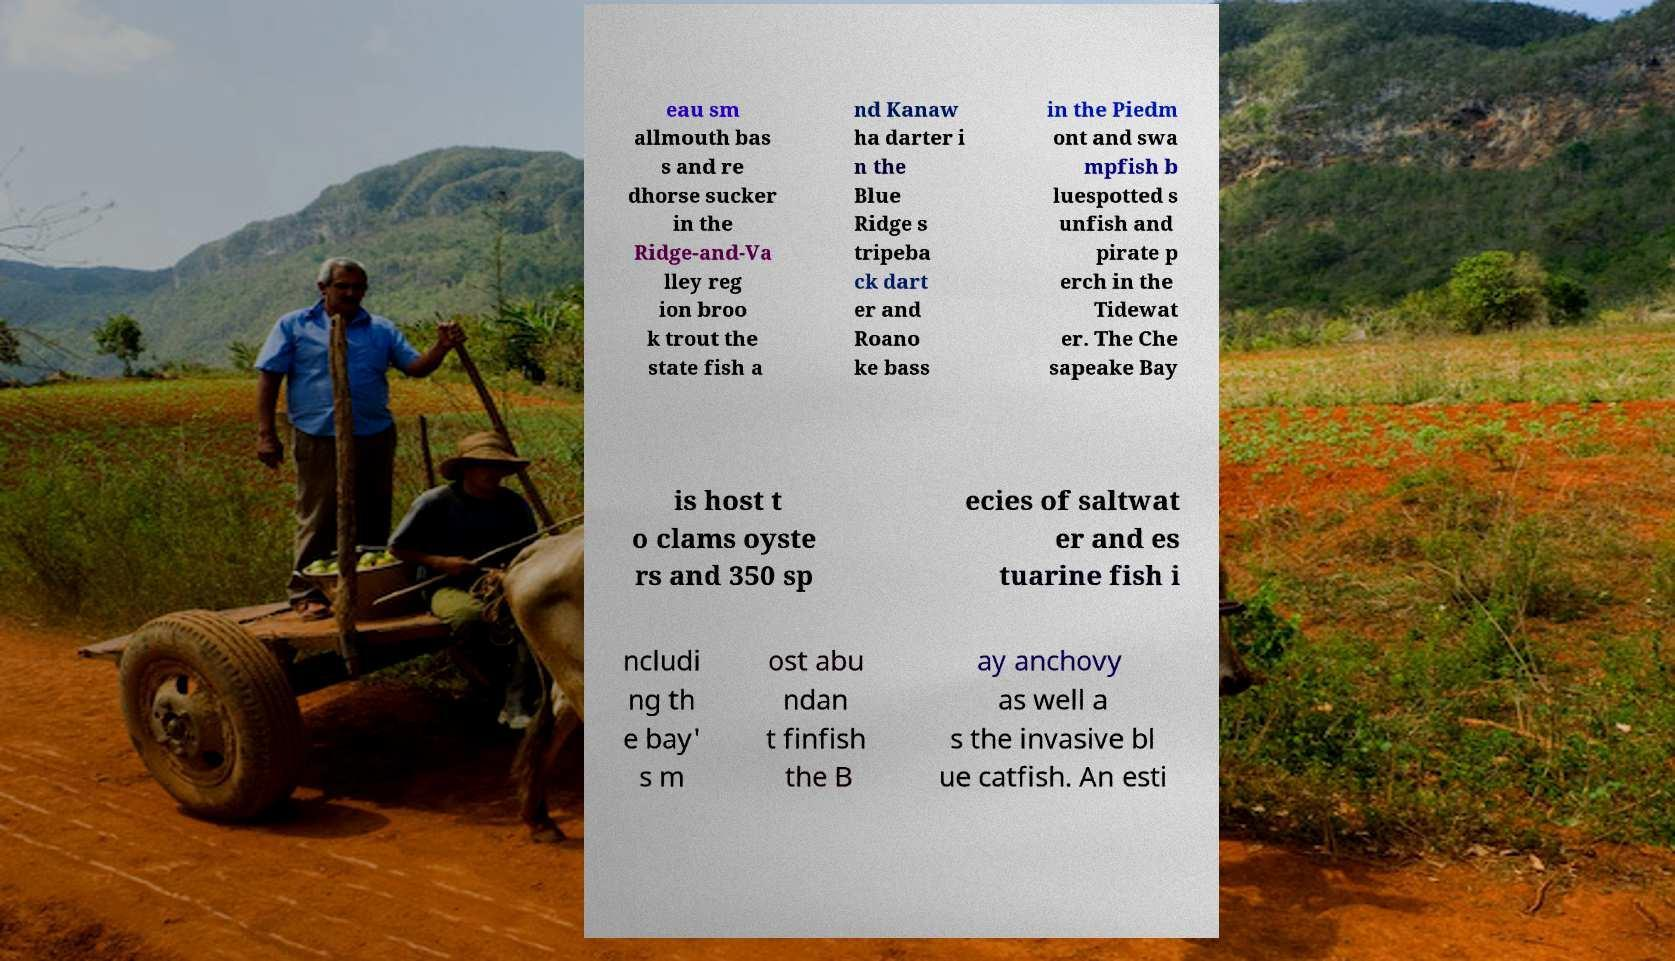Could you extract and type out the text from this image? eau sm allmouth bas s and re dhorse sucker in the Ridge-and-Va lley reg ion broo k trout the state fish a nd Kanaw ha darter i n the Blue Ridge s tripeba ck dart er and Roano ke bass in the Piedm ont and swa mpfish b luespotted s unfish and pirate p erch in the Tidewat er. The Che sapeake Bay is host t o clams oyste rs and 350 sp ecies of saltwat er and es tuarine fish i ncludi ng th e bay' s m ost abu ndan t finfish the B ay anchovy as well a s the invasive bl ue catfish. An esti 